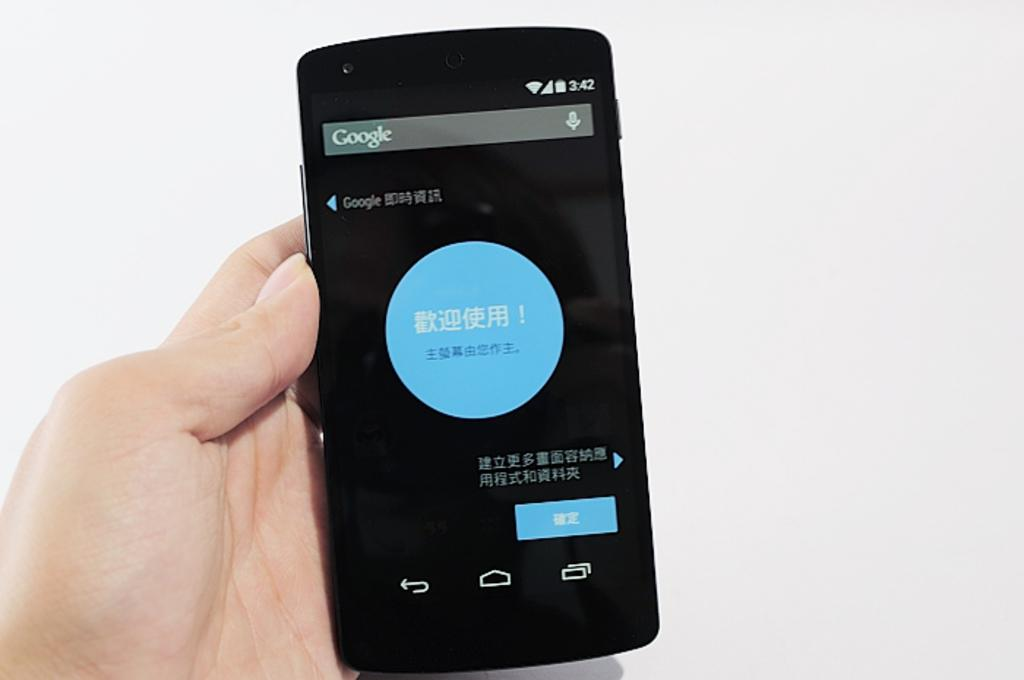What is the person holding in the image? A person's hand is holding a mobile in the image. What can be seen on the mobile? There is writing on the mobile. What color is the background of the image? The background of the image is white. What type of curtain is hanging in front of the person in the image? There is no curtain present in the image. What is the source of the flame in the image? There is no flame present in the image. 